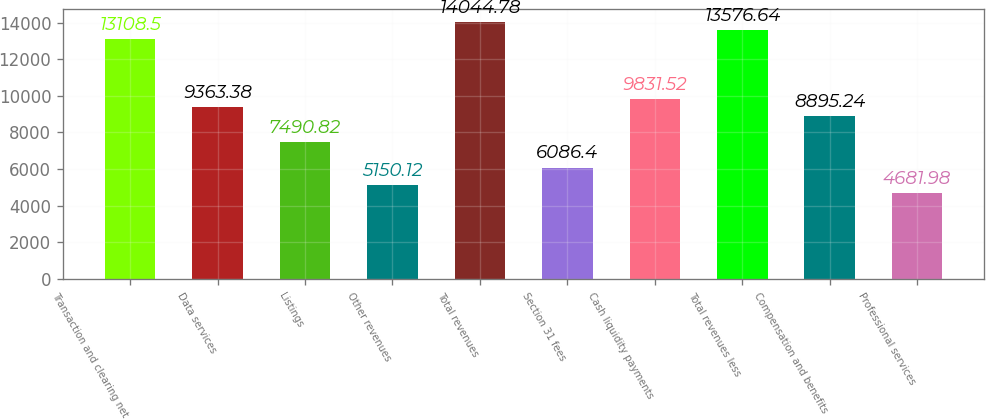<chart> <loc_0><loc_0><loc_500><loc_500><bar_chart><fcel>Transaction and clearing net<fcel>Data services<fcel>Listings<fcel>Other revenues<fcel>Total revenues<fcel>Section 31 fees<fcel>Cash liquidity payments<fcel>Total revenues less<fcel>Compensation and benefits<fcel>Professional services<nl><fcel>13108.5<fcel>9363.38<fcel>7490.82<fcel>5150.12<fcel>14044.8<fcel>6086.4<fcel>9831.52<fcel>13576.6<fcel>8895.24<fcel>4681.98<nl></chart> 